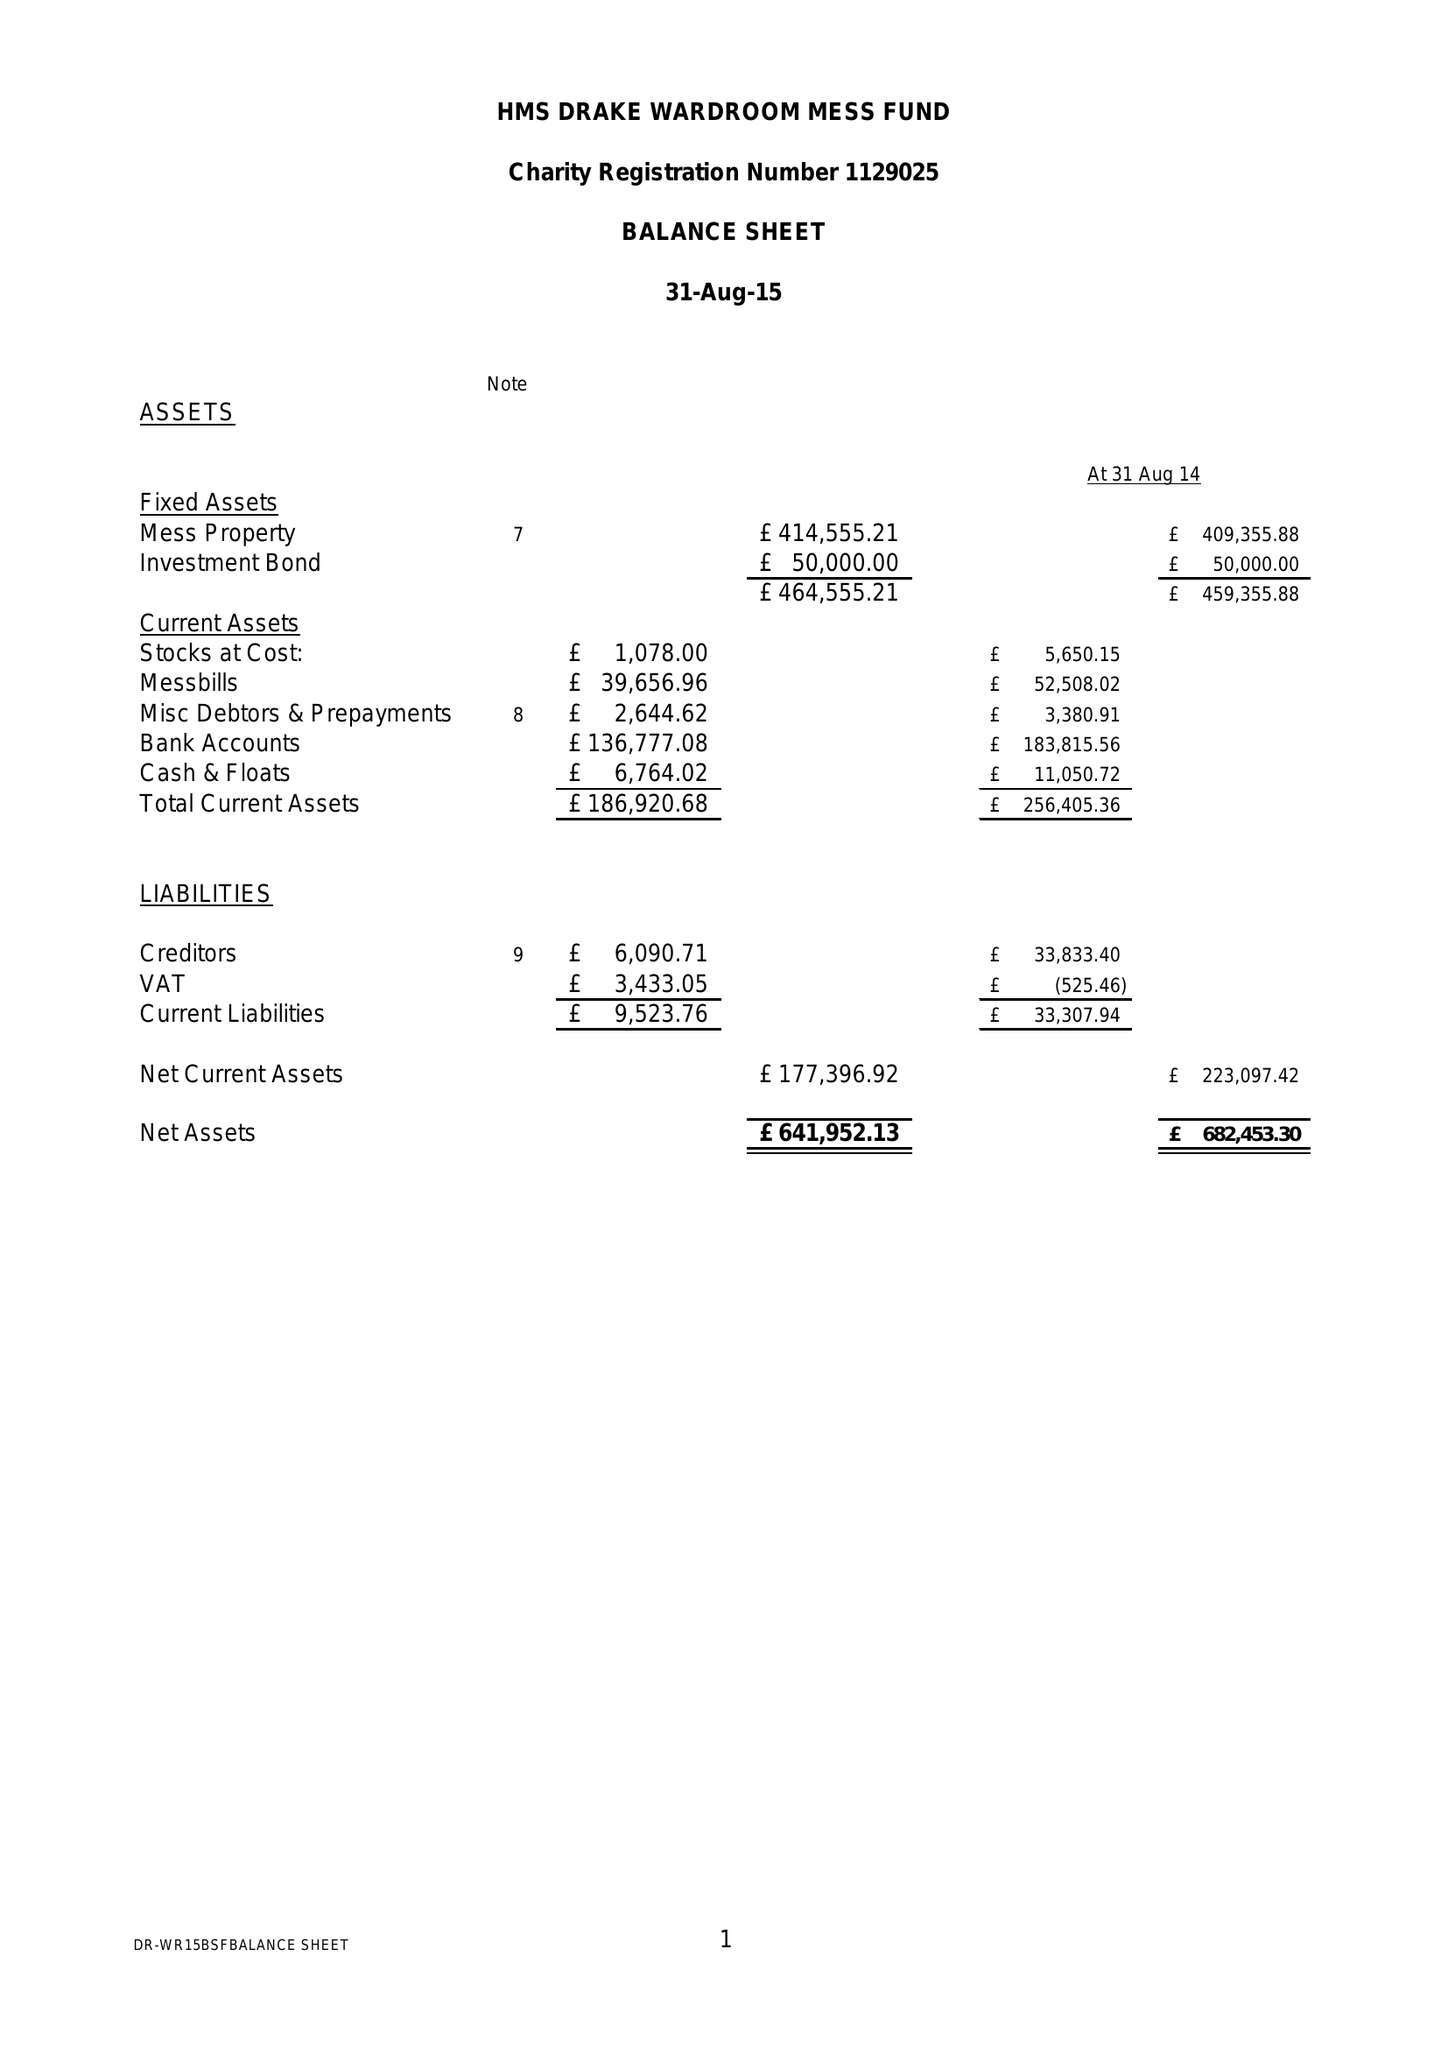What is the value for the report_date?
Answer the question using a single word or phrase. 2015-08-31 